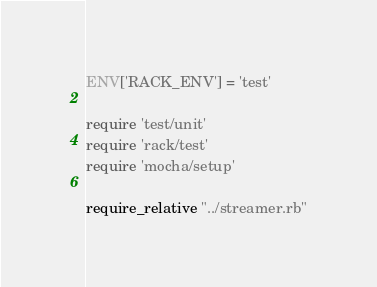Convert code to text. <code><loc_0><loc_0><loc_500><loc_500><_Ruby_>ENV['RACK_ENV'] = 'test'

require 'test/unit'
require 'rack/test'
require 'mocha/setup'

require_relative "../streamer.rb"</code> 